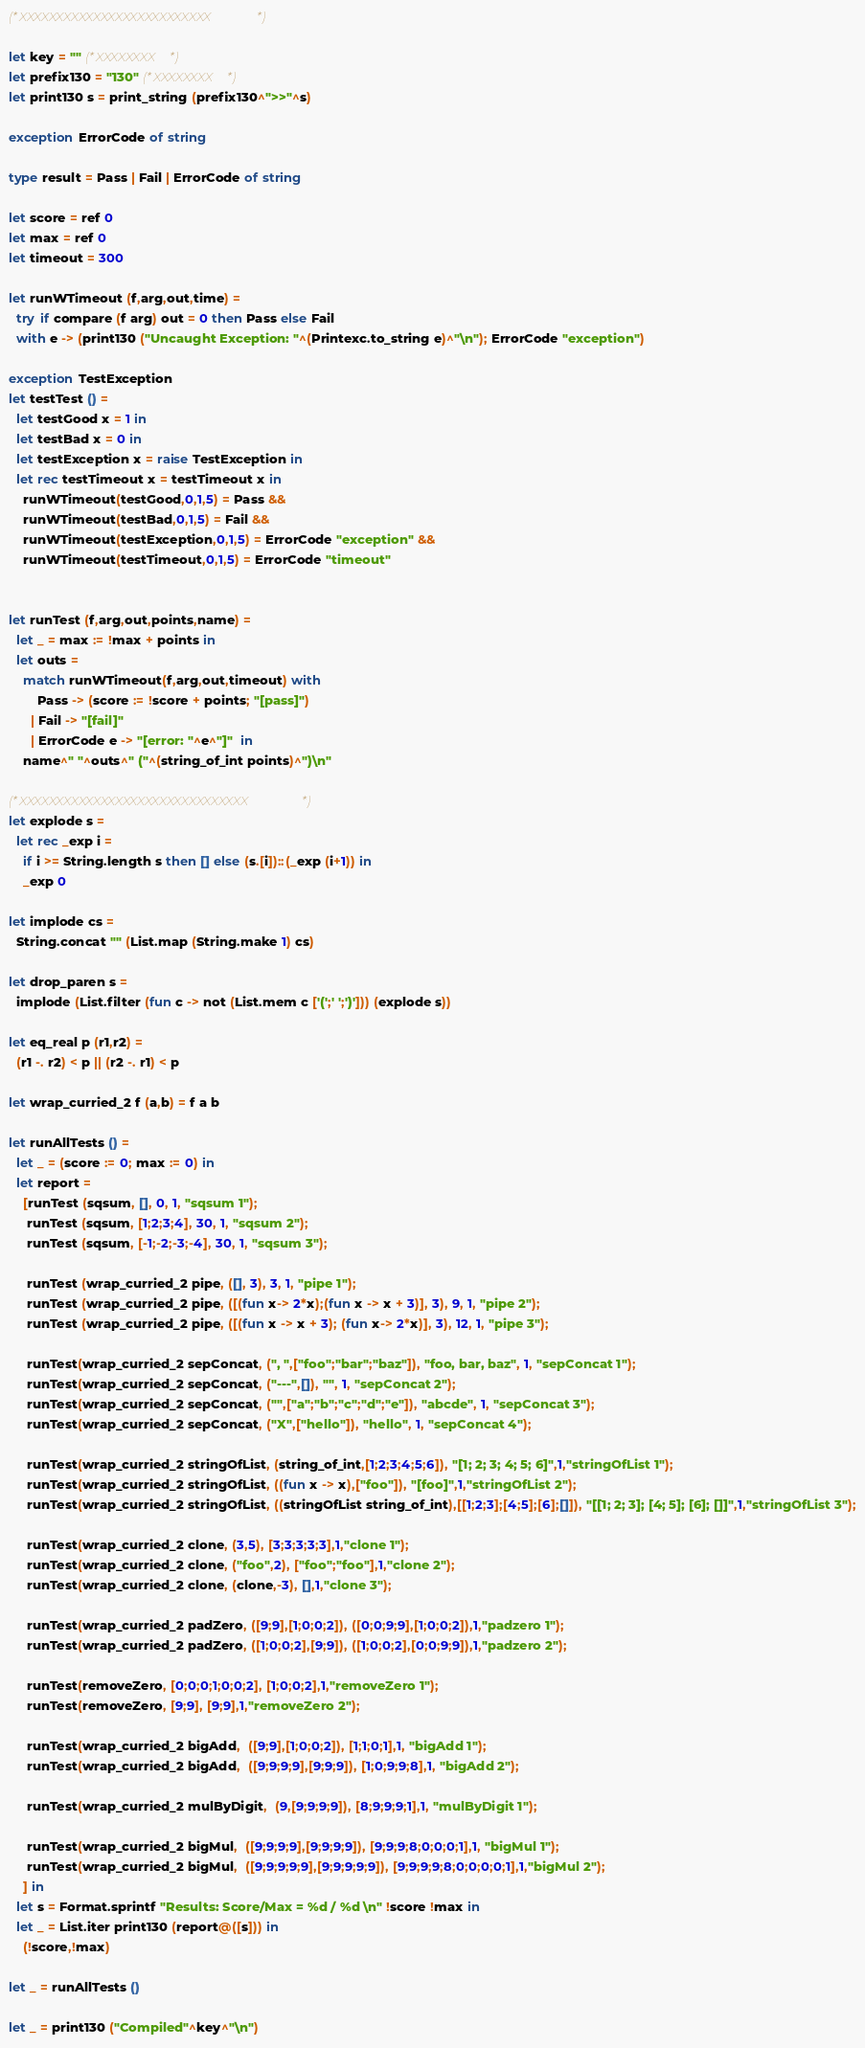<code> <loc_0><loc_0><loc_500><loc_500><_OCaml_>






















(*XXXXXXXXXXXXXXXXXXXXXXXXXX*)

let key = "" (*XXXXXXXX*)
let prefix130 = "130" (*XXXXXXXX*)
let print130 s = print_string (prefix130^">>"^s)

exception ErrorCode of string

type result = Pass | Fail | ErrorCode of string

let score = ref 0
let max = ref 0
let timeout = 300

let runWTimeout (f,arg,out,time) = 
  try if compare (f arg) out = 0 then Pass else Fail
  with e -> (print130 ("Uncaught Exception: "^(Printexc.to_string e)^"\n"); ErrorCode "exception") 

exception TestException
let testTest () =
  let testGood x = 1 in
  let testBad x = 0 in 
  let testException x = raise TestException in
  let rec testTimeout x = testTimeout x in
    runWTimeout(testGood,0,1,5) = Pass &&  
    runWTimeout(testBad,0,1,5) = Fail &&  
    runWTimeout(testException,0,1,5) = ErrorCode "exception" && 
    runWTimeout(testTimeout,0,1,5) = ErrorCode "timeout"


let runTest (f,arg,out,points,name) =
  let _ = max := !max + points in
  let outs = 
    match runWTimeout(f,arg,out,timeout) with 
        Pass -> (score := !score + points; "[pass]")
      | Fail -> "[fail]"
      | ErrorCode e -> "[error: "^e^"]"  in
    name^" "^outs^" ("^(string_of_int points)^")\n"

(*XXXXXXXXXXXXXXXXXXXXXXXXXXXXXXX*)
let explode s = 
  let rec _exp i = 
    if i >= String.length s then [] else (s.[i])::(_exp (i+1)) in
    _exp 0

let implode cs = 
  String.concat "" (List.map (String.make 1) cs)

let drop_paren s = 
  implode (List.filter (fun c -> not (List.mem c ['(';' ';')'])) (explode s))

let eq_real p (r1,r2) = 
  (r1 -. r2) < p || (r2 -. r1) < p

let wrap_curried_2 f (a,b) = f a b

let runAllTests () =
  let _ = (score := 0; max := 0) in
  let report = 
    [runTest (sqsum, [], 0, 1, "sqsum 1");
     runTest (sqsum, [1;2;3;4], 30, 1, "sqsum 2");
     runTest (sqsum, [-1;-2;-3;-4], 30, 1, "sqsum 3");

     runTest (wrap_curried_2 pipe, ([], 3), 3, 1, "pipe 1");
     runTest (wrap_curried_2 pipe, ([(fun x-> 2*x);(fun x -> x + 3)], 3), 9, 1, "pipe 2");
     runTest (wrap_curried_2 pipe, ([(fun x -> x + 3); (fun x-> 2*x)], 3), 12, 1, "pipe 3");

     runTest(wrap_curried_2 sepConcat, (", ",["foo";"bar";"baz"]), "foo, bar, baz", 1, "sepConcat 1");
     runTest(wrap_curried_2 sepConcat, ("---",[]), "", 1, "sepConcat 2");
     runTest(wrap_curried_2 sepConcat, ("",["a";"b";"c";"d";"e"]), "abcde", 1, "sepConcat 3");
     runTest(wrap_curried_2 sepConcat, ("X",["hello"]), "hello", 1, "sepConcat 4");

     runTest(wrap_curried_2 stringOfList, (string_of_int,[1;2;3;4;5;6]), "[1; 2; 3; 4; 5; 6]",1,"stringOfList 1");
     runTest(wrap_curried_2 stringOfList, ((fun x -> x),["foo"]), "[foo]",1,"stringOfList 2");
     runTest(wrap_curried_2 stringOfList, ((stringOfList string_of_int),[[1;2;3];[4;5];[6];[]]), "[[1; 2; 3]; [4; 5]; [6]; []]",1,"stringOfList 3");

     runTest(wrap_curried_2 clone, (3,5), [3;3;3;3;3],1,"clone 1");
     runTest(wrap_curried_2 clone, ("foo",2), ["foo";"foo"],1,"clone 2");
     runTest(wrap_curried_2 clone, (clone,-3), [],1,"clone 3");

     runTest(wrap_curried_2 padZero, ([9;9],[1;0;0;2]), ([0;0;9;9],[1;0;0;2]),1,"padzero 1");
     runTest(wrap_curried_2 padZero, ([1;0;0;2],[9;9]), ([1;0;0;2],[0;0;9;9]),1,"padzero 2");

     runTest(removeZero, [0;0;0;1;0;0;2], [1;0;0;2],1,"removeZero 1");
     runTest(removeZero, [9;9], [9;9],1,"removeZero 2");

     runTest(wrap_curried_2 bigAdd,  ([9;9],[1;0;0;2]), [1;1;0;1],1, "bigAdd 1");
     runTest(wrap_curried_2 bigAdd,  ([9;9;9;9],[9;9;9]), [1;0;9;9;8],1, "bigAdd 2");

     runTest(wrap_curried_2 mulByDigit,  (9,[9;9;9;9]), [8;9;9;9;1],1, "mulByDigit 1");

     runTest(wrap_curried_2 bigMul,  ([9;9;9;9],[9;9;9;9]), [9;9;9;8;0;0;0;1],1, "bigMul 1");
     runTest(wrap_curried_2 bigMul,  ([9;9;9;9;9],[9;9;9;9;9]), [9;9;9;9;8;0;0;0;0;1],1,"bigMul 2");
    ] in
  let s = Format.sprintf "Results: Score/Max = %d / %d \n" !score !max in
  let _ = List.iter print130 (report@([s])) in
    (!score,!max)

let _ = runAllTests ()

let _ = print130 ("Compiled"^key^"\n")


</code> 